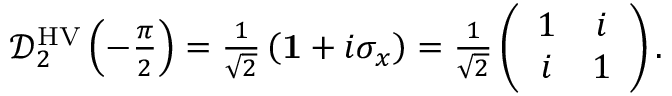<formula> <loc_0><loc_0><loc_500><loc_500>\begin{array} { r } { \mathcal { D } _ { 2 } ^ { H V } \left ( - \frac { \pi } { 2 } \right ) = \frac { 1 } { \sqrt { 2 } } \left ( { 1 } + i \sigma _ { x } \right ) = \frac { 1 } { \sqrt { 2 } } \left ( \begin{array} { c c } { 1 } & { i } \\ { i } & { 1 } \end{array} \right ) . } \end{array}</formula> 